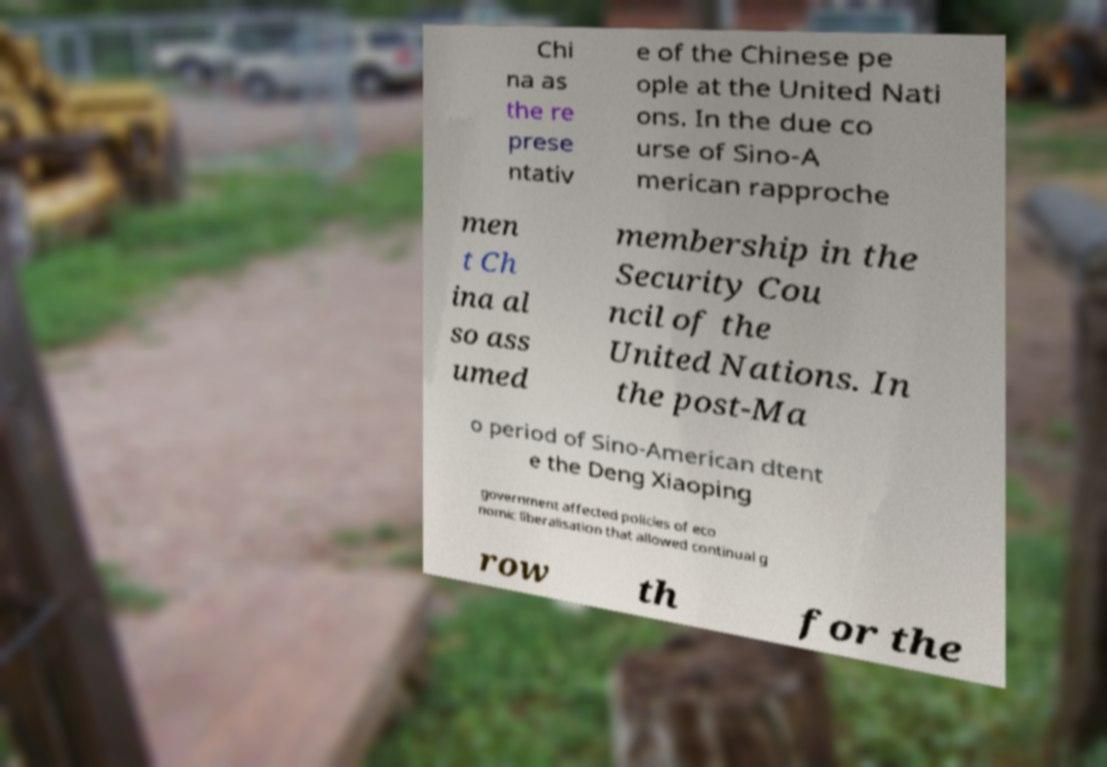Could you assist in decoding the text presented in this image and type it out clearly? Chi na as the re prese ntativ e of the Chinese pe ople at the United Nati ons. In the due co urse of Sino-A merican rapproche men t Ch ina al so ass umed membership in the Security Cou ncil of the United Nations. In the post-Ma o period of Sino-American dtent e the Deng Xiaoping government affected policies of eco nomic liberalisation that allowed continual g row th for the 